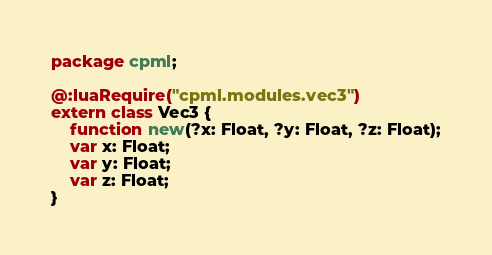<code> <loc_0><loc_0><loc_500><loc_500><_Haxe_>package cpml;

@:luaRequire("cpml.modules.vec3")
extern class Vec3 {
	function new(?x: Float, ?y: Float, ?z: Float);
	var x: Float;
	var y: Float;
	var z: Float;
}
</code> 